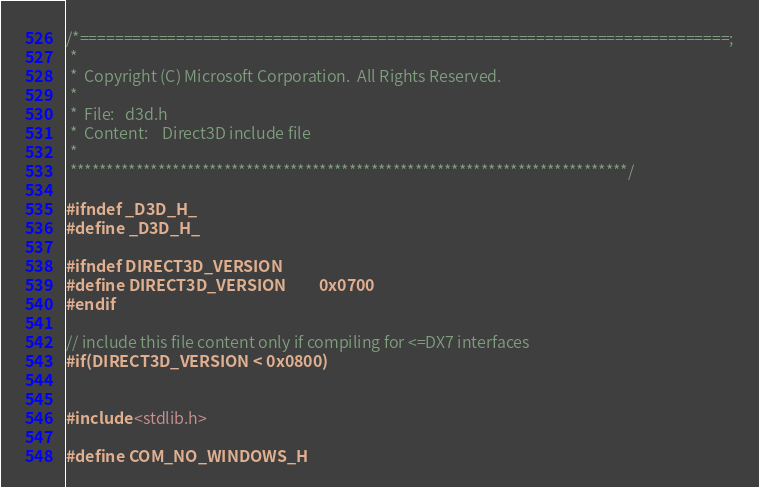<code> <loc_0><loc_0><loc_500><loc_500><_C_>/*==========================================================================;
 *
 *  Copyright (C) Microsoft Corporation.  All Rights Reserved.
 *
 *  File:   d3d.h
 *  Content:    Direct3D include file
 *
 ****************************************************************************/

#ifndef _D3D_H_
#define _D3D_H_

#ifndef DIRECT3D_VERSION
#define DIRECT3D_VERSION         0x0700
#endif

// include this file content only if compiling for <=DX7 interfaces
#if(DIRECT3D_VERSION < 0x0800)


#include <stdlib.h>

#define COM_NO_WINDOWS_H</code> 